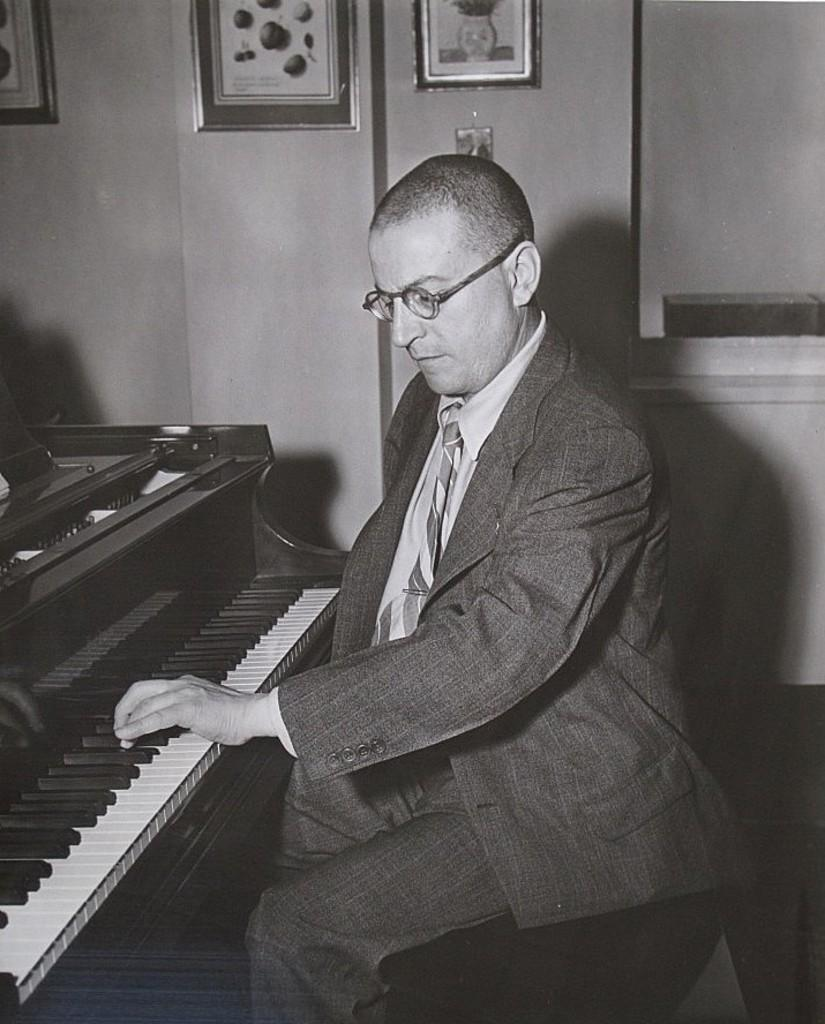What is the person in the image doing? There is a person sitting in the image. What object can be seen in the image besides the person? There is a piano in the image. What is visible in the background of the image? There is a wall in the background of the image. What is attached to the wall in the background? There are photo frames attached to the wall in the background. What type of sand can be seen on the beach in the image? There is no beach or sand present in the image; it features a person sitting near a piano with a wall and photo frames in the background. 